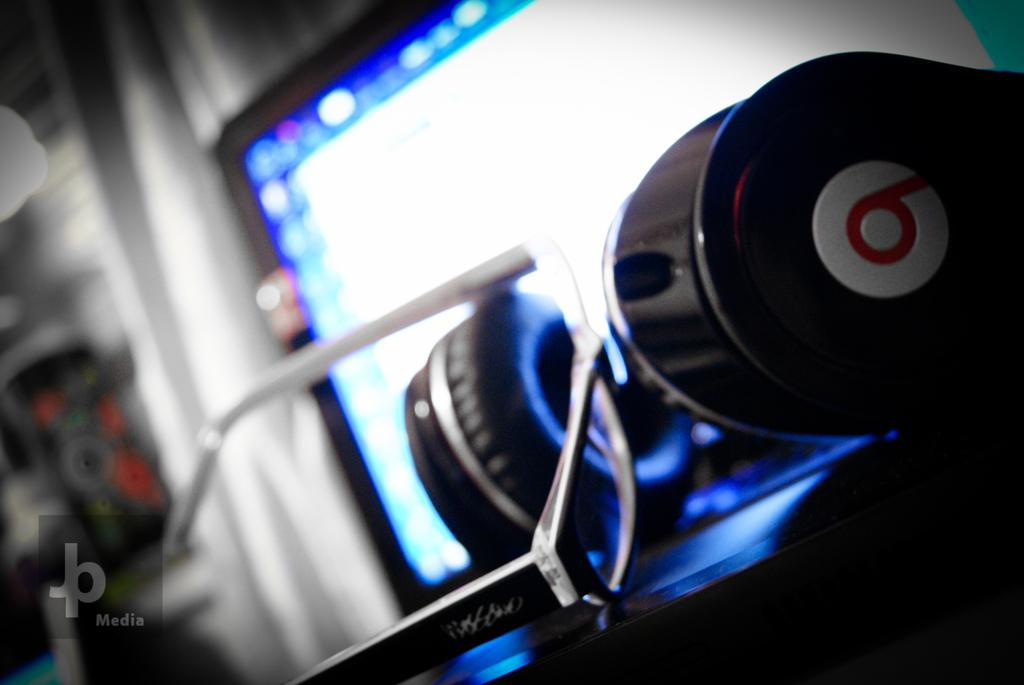What type of accessory is visible in the image? There are spectacles and headphones in the image. What electronic device is present in the image? There is a laptop in the image. How is the background behind the laptop depicted? The background behind the laptop is blurred. Is there any indication of ownership or origin on the image? Yes, there is a watermark on the image. What type of theory can be seen being tested in the image? There is no theory being tested in the image. 